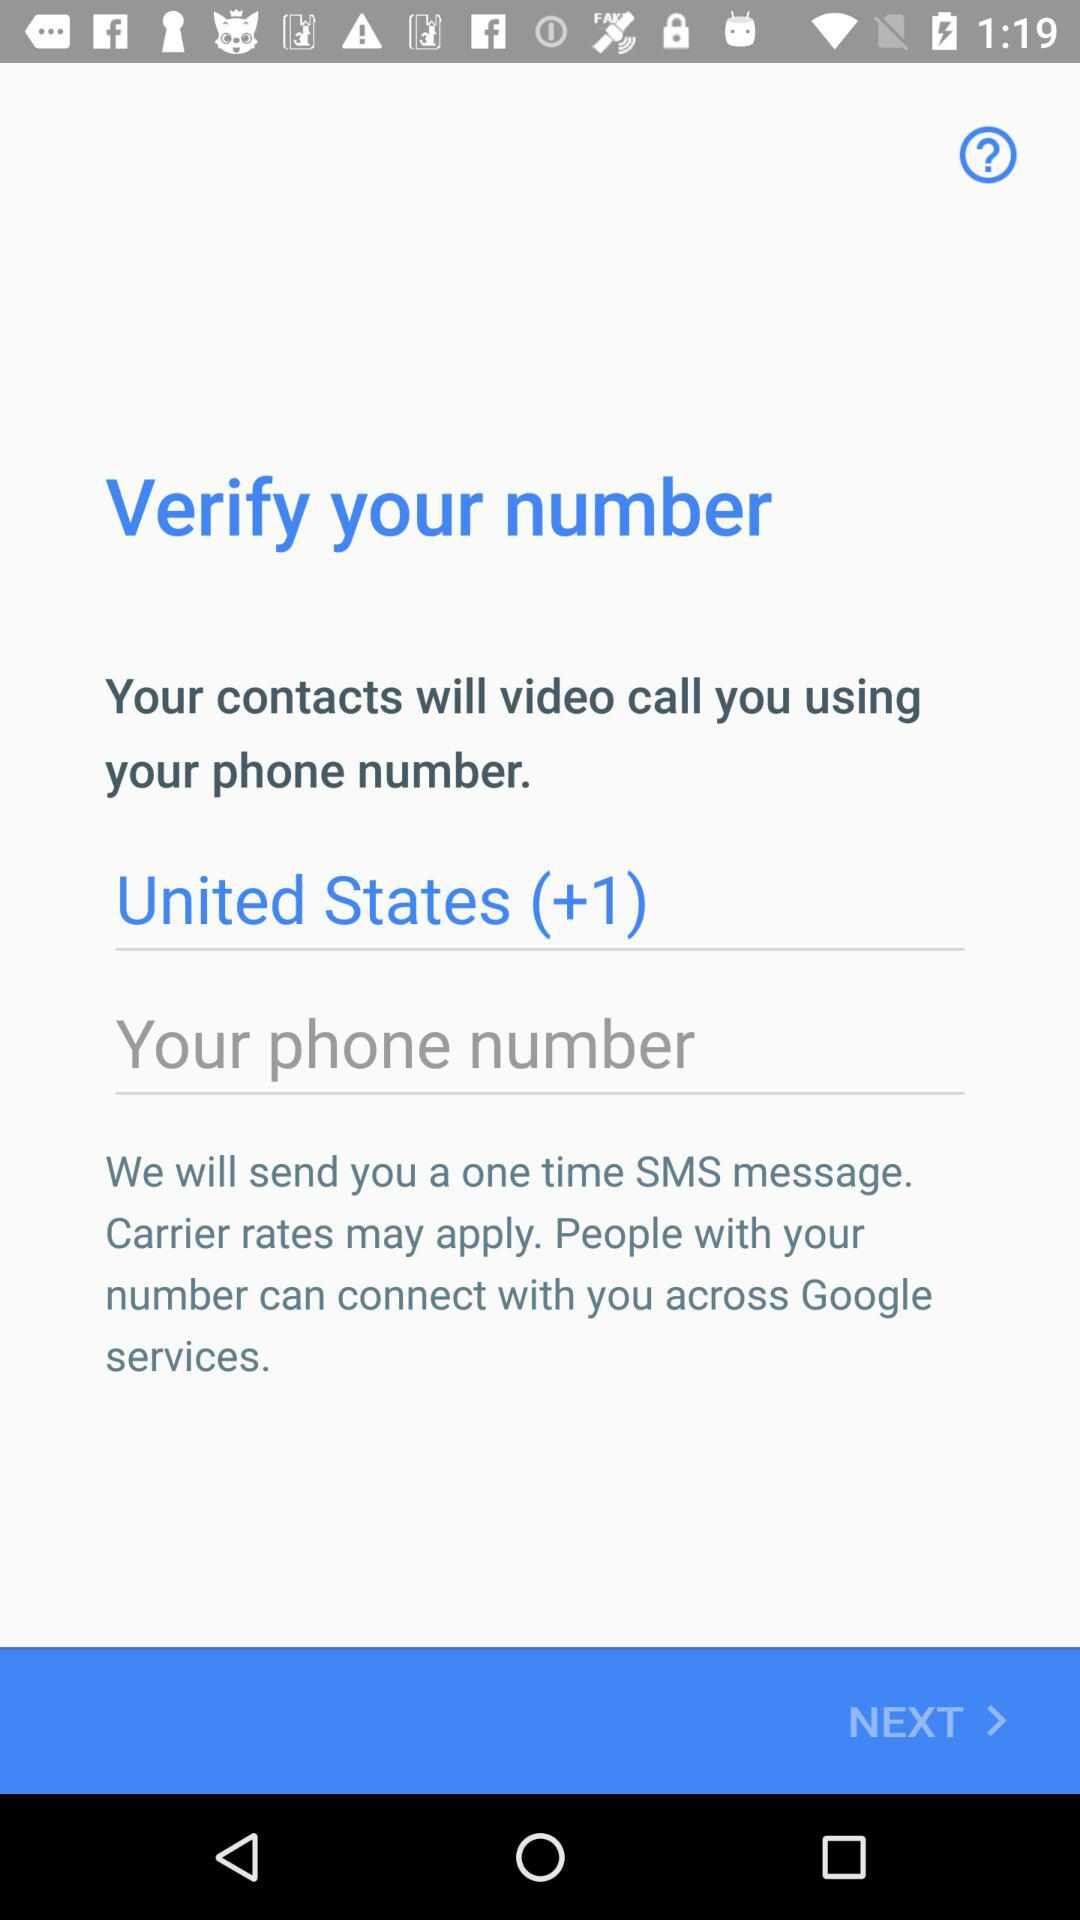What is the current location? The current location is in the United States. 